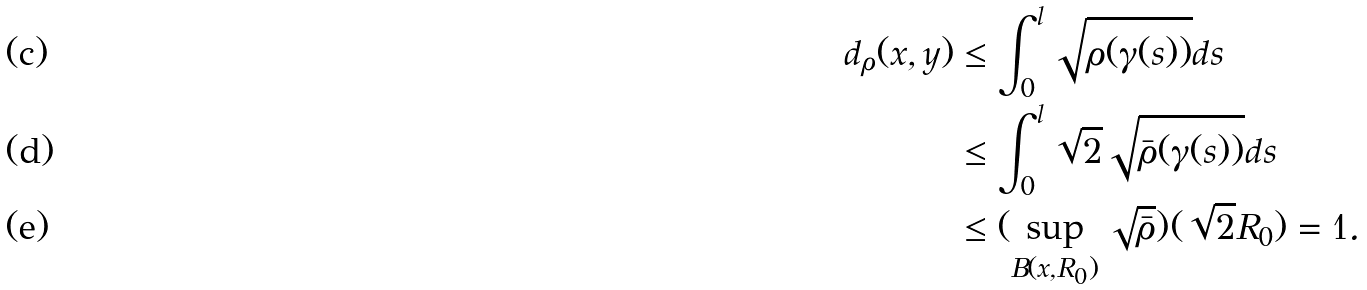Convert formula to latex. <formula><loc_0><loc_0><loc_500><loc_500>d _ { \rho } ( x , y ) & \leq \int _ { 0 } ^ { l } \sqrt { \rho ( \gamma ( s ) ) } d s \\ & \leq \int _ { 0 } ^ { l } \sqrt { 2 } \sqrt { \bar { \rho } ( \gamma ( s ) ) } d s \\ & \leq ( \sup _ { B ( x , R _ { 0 } ) } \sqrt { \bar { \rho } } ) ( \sqrt { 2 } R _ { 0 } ) = 1 .</formula> 